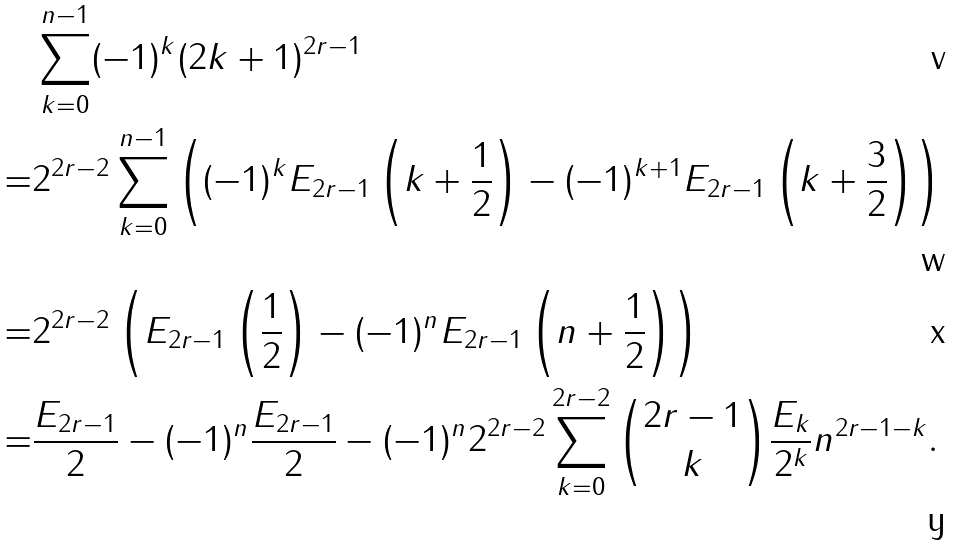Convert formula to latex. <formula><loc_0><loc_0><loc_500><loc_500>& \sum _ { k = 0 } ^ { n - 1 } ( - 1 ) ^ { k } ( 2 k + 1 ) ^ { 2 r - 1 } \\ = & 2 ^ { 2 r - 2 } \sum _ { k = 0 } ^ { n - 1 } \left ( ( - 1 ) ^ { k } E _ { 2 r - 1 } \left ( k + \frac { 1 } { 2 } \right ) - ( - 1 ) ^ { k + 1 } E _ { 2 r - 1 } \left ( k + \frac { 3 } { 2 } \right ) \right ) \\ = & 2 ^ { 2 r - 2 } \left ( E _ { 2 r - 1 } \left ( \frac { 1 } { 2 } \right ) - ( - 1 ) ^ { n } E _ { 2 r - 1 } \left ( n + \frac { 1 } { 2 } \right ) \right ) \\ = & \frac { E _ { 2 r - 1 } } 2 - ( - 1 ) ^ { n } \frac { E _ { 2 r - 1 } } 2 - ( - 1 ) ^ { n } 2 ^ { 2 r - 2 } \sum _ { k = 0 } ^ { 2 r - 2 } \binom { 2 r - 1 } k \frac { E _ { k } } { 2 ^ { k } } n ^ { 2 r - 1 - k } .</formula> 